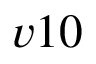Convert formula to latex. <formula><loc_0><loc_0><loc_500><loc_500>v 1 0</formula> 